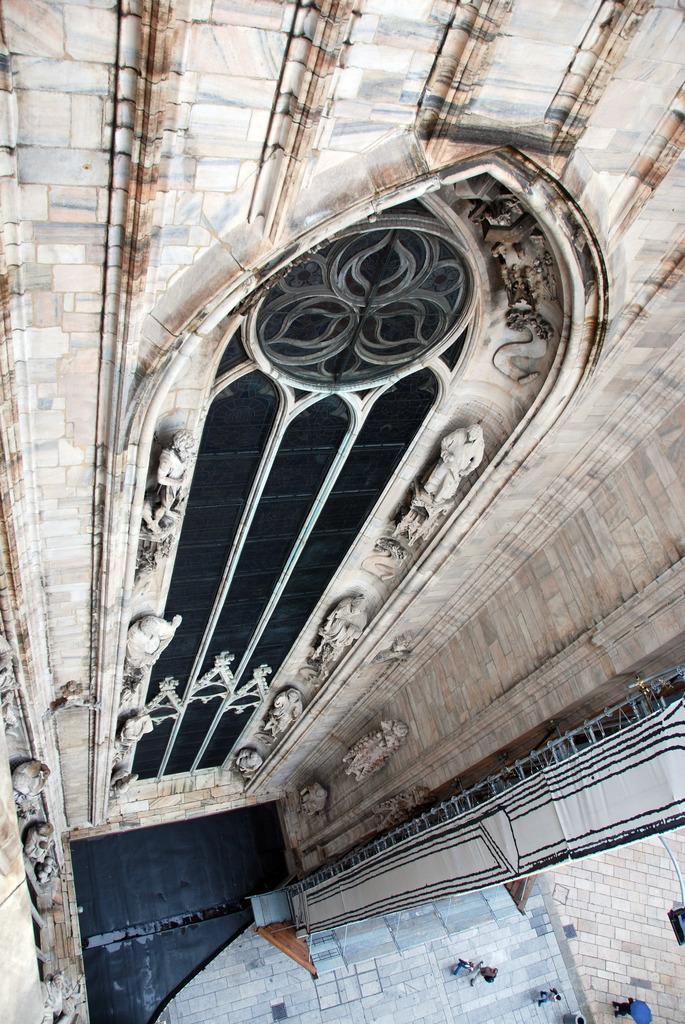Could you give a brief overview of what you see in this image? In the image we can see an arch window. Here we can see sculpture on the side of the window. Here we can see a stone wall and we can see there are even people wearing clothes and this is a footpath. 